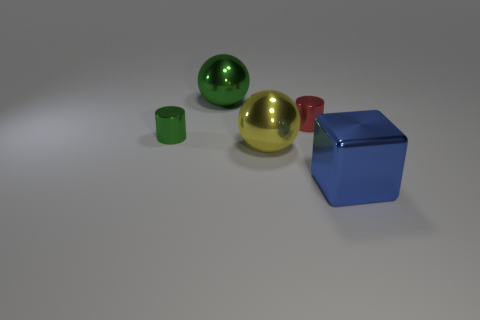Are there more red objects in front of the big blue cube than yellow metal objects behind the small red shiny cylinder?
Make the answer very short. No. How many small red objects are left of the thing that is right of the red metallic thing?
Keep it short and to the point. 1. There is a large shiny thing that is in front of the large yellow sphere; does it have the same shape as the yellow thing?
Your answer should be compact. No. What is the material of the green object that is the same shape as the small red thing?
Keep it short and to the point. Metal. What number of red metallic objects are the same size as the green cylinder?
Offer a terse response. 1. What is the color of the object that is both on the right side of the yellow shiny ball and left of the big metal block?
Provide a short and direct response. Red. Is the number of blue metal blocks less than the number of big brown objects?
Give a very brief answer. No. There is a large cube; does it have the same color as the large ball behind the tiny red metal thing?
Make the answer very short. No. Are there the same number of cubes that are behind the large green metal object and red shiny cylinders left of the green cylinder?
Provide a succinct answer. Yes. What number of other big blue metal objects have the same shape as the blue object?
Offer a very short reply. 0. 